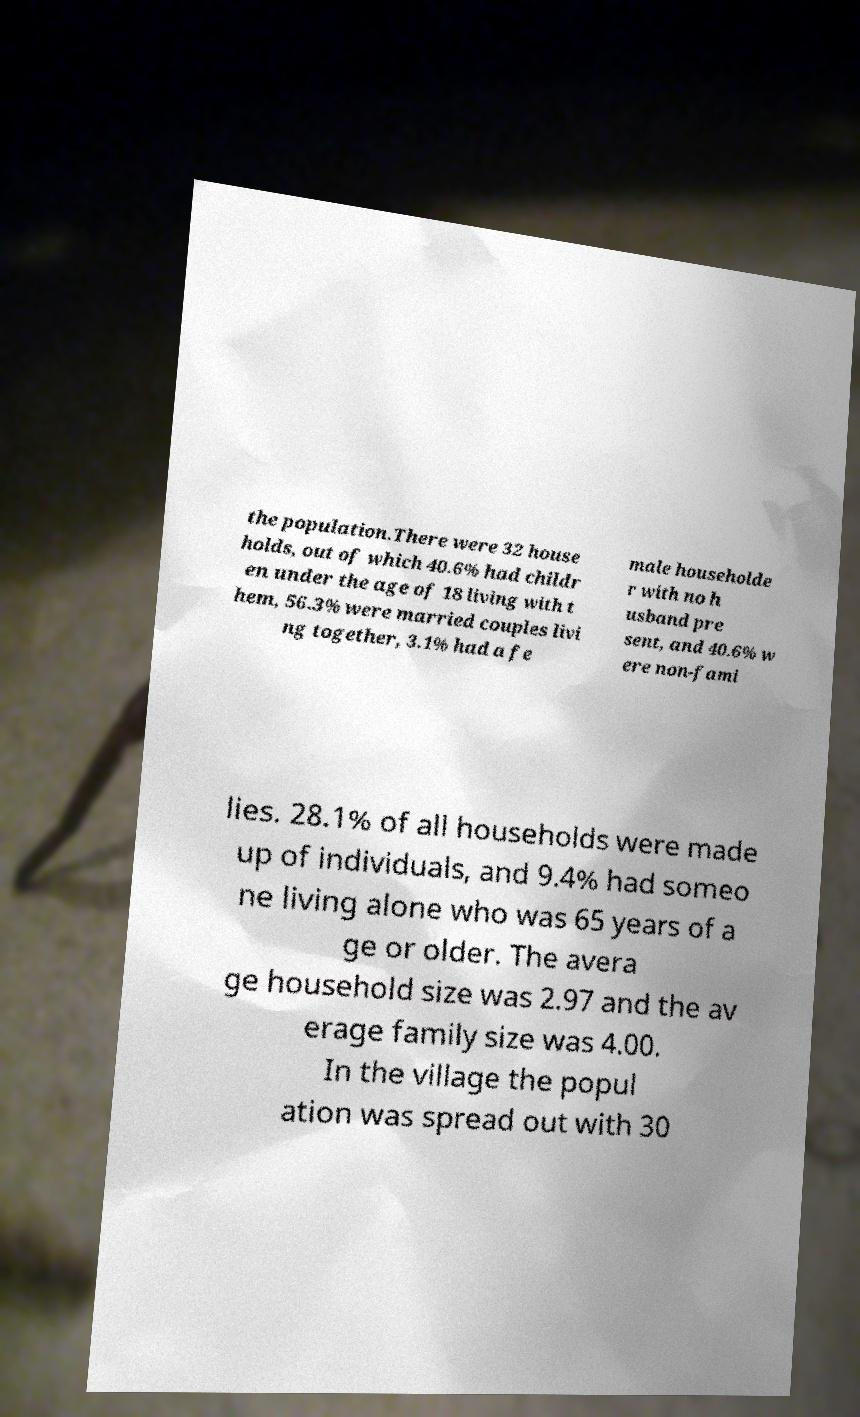Can you read and provide the text displayed in the image?This photo seems to have some interesting text. Can you extract and type it out for me? the population.There were 32 house holds, out of which 40.6% had childr en under the age of 18 living with t hem, 56.3% were married couples livi ng together, 3.1% had a fe male householde r with no h usband pre sent, and 40.6% w ere non-fami lies. 28.1% of all households were made up of individuals, and 9.4% had someo ne living alone who was 65 years of a ge or older. The avera ge household size was 2.97 and the av erage family size was 4.00. In the village the popul ation was spread out with 30 